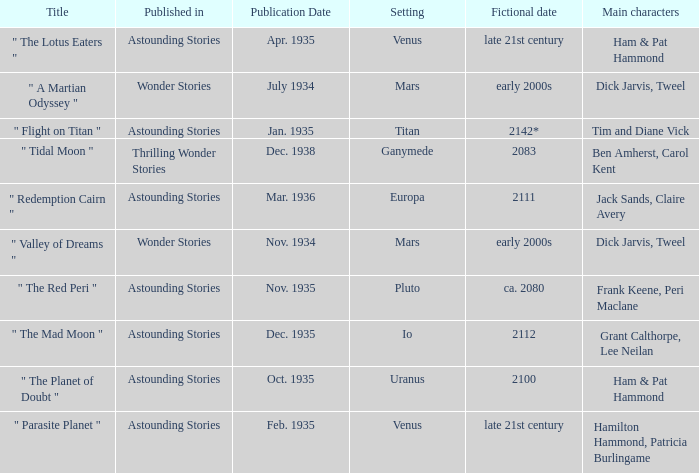Name what was published in july 1934 with a setting of mars Wonder Stories. 